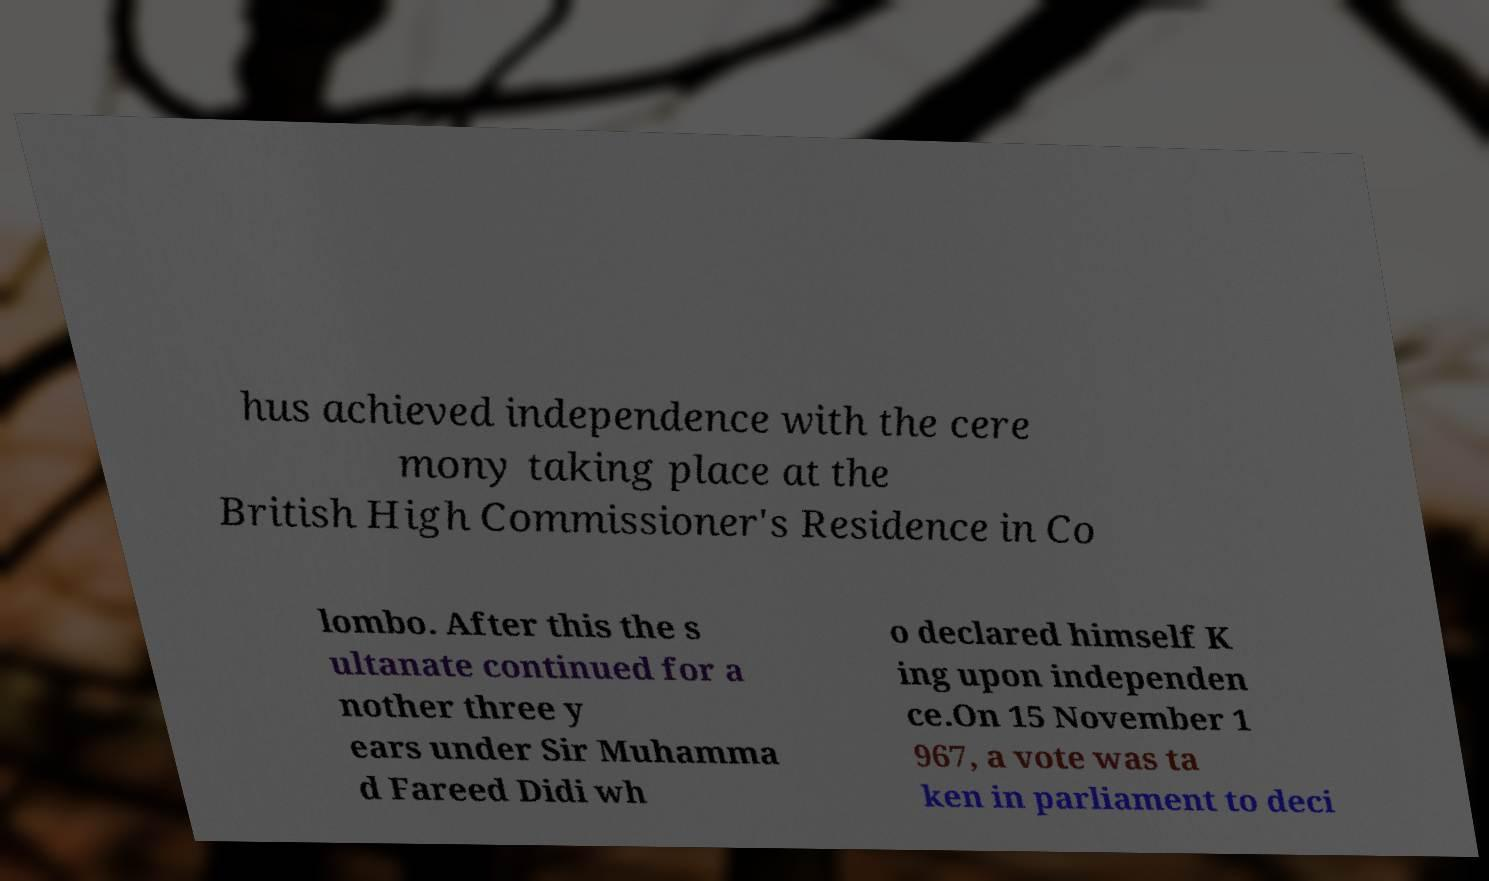There's text embedded in this image that I need extracted. Can you transcribe it verbatim? hus achieved independence with the cere mony taking place at the British High Commissioner's Residence in Co lombo. After this the s ultanate continued for a nother three y ears under Sir Muhamma d Fareed Didi wh o declared himself K ing upon independen ce.On 15 November 1 967, a vote was ta ken in parliament to deci 